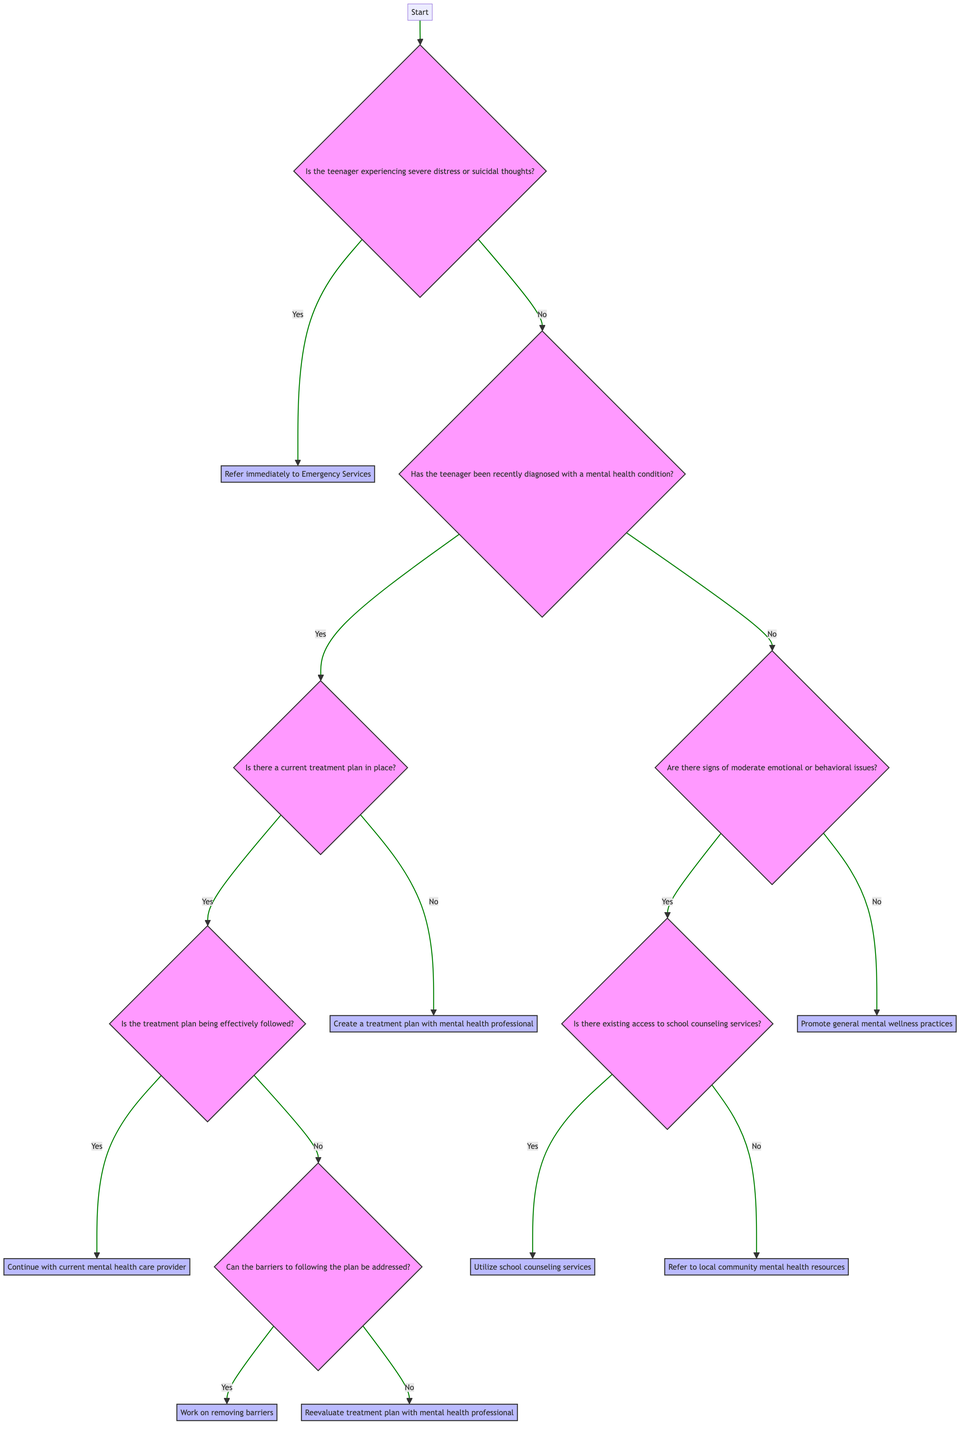Is the starting question about severe distress or suicidal thoughts? The first question branching from the start in the decision tree is indeed about whether the teenager is experiencing severe distress or suicidal thoughts. This provides clarity on the immediate action needed.
Answer: Yes How many main paths are available after the initial question? After the initial question about severe distress, there are two main paths: one leading to immediate referral to emergency services if "Yes" and another leading to a series of further questions if "No." This represents two distinct paths.
Answer: 2 What action is taken if there is no treatment plan in place but there is a diagnosis? If the teenager has a diagnosis but no treatment plan, the action taken is to create a treatment plan with a mental health professional. This indicates the necessity of formulating a structured approach to treatment.
Answer: Create a treatment plan with mental health professional What happens if the treatment plan is not being effectively followed? If the treatment plan is not being effectively followed, the next question is whether the barriers to following the plan can be addressed. Depending on the answer, different actions will be taken, either working on removing barriers or reevaluating the treatment plan with a professional.
Answer: Can the barriers to following the plan be addressed? What should be done if there are moderate emotional or behavioral issues and no school counseling services? In the scenario where moderate emotional or behavioral issues are present but there are no existing school counseling services, the recommendation is to refer to local community mental health resources. This provides an alternative support option.
Answer: Refer to local community mental health resources What is the final action if there are no signs of emotional or behavioral issues? If there are no signs of emotional or behavioral issues, the recommended action is to promote general mental wellness practices. This encompasses various proactive health measures to maintain well-being.
Answer: Promote general mental wellness practices 